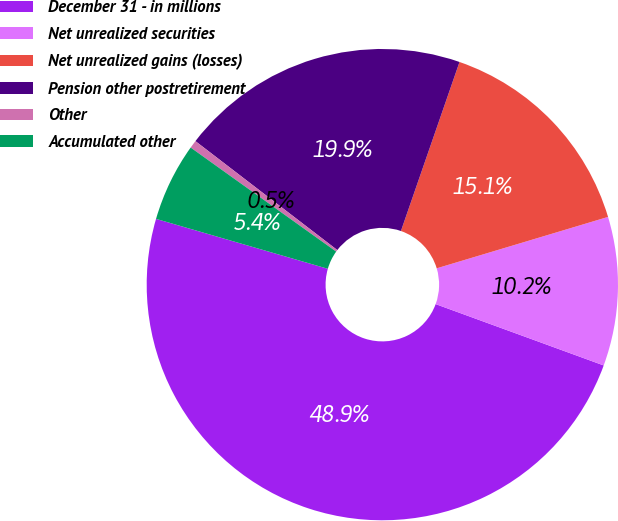Convert chart to OTSL. <chart><loc_0><loc_0><loc_500><loc_500><pie_chart><fcel>December 31 - in millions<fcel>Net unrealized securities<fcel>Net unrealized gains (losses)<fcel>Pension other postretirement<fcel>Other<fcel>Accumulated other<nl><fcel>48.93%<fcel>10.21%<fcel>15.05%<fcel>19.89%<fcel>0.54%<fcel>5.38%<nl></chart> 